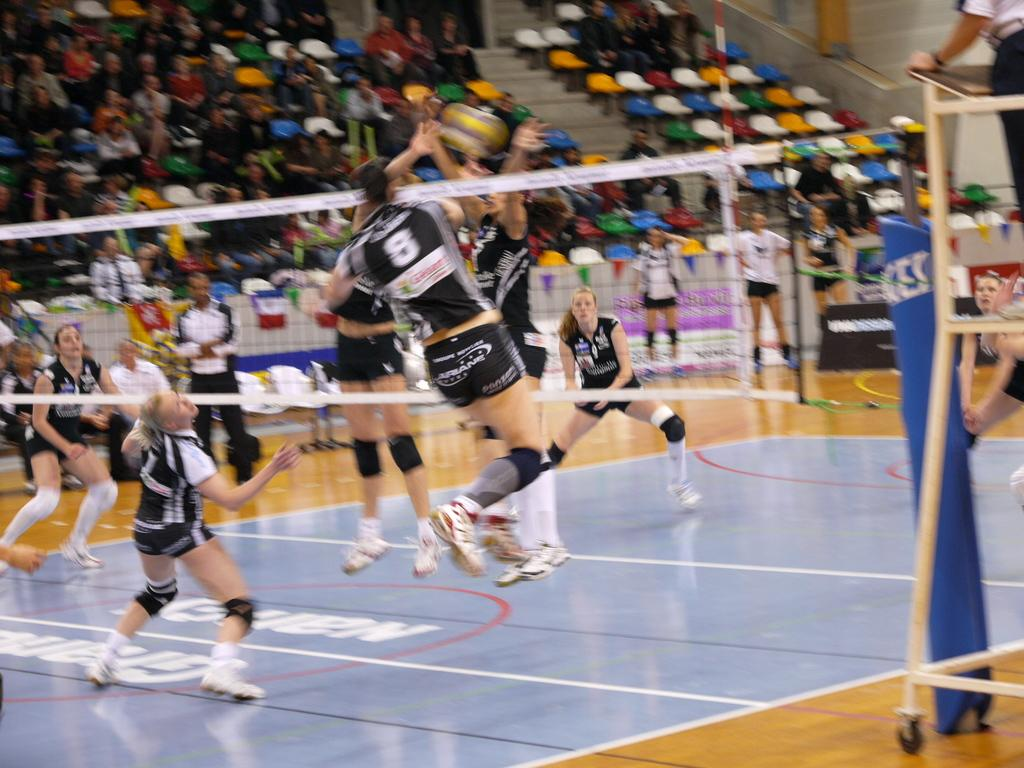What activity are the people in the image engaged in? The people in the image are playing throw ball. Can you describe the setting of the image? There is an audience in the background of the image. How would you describe the quality of the image? The image is blurred. How many pizzas are being served to the audience in the image? There are no pizzas visible in the image. What type of mitten is being worn by the person playing throw ball? There is no mitten present in the image. 